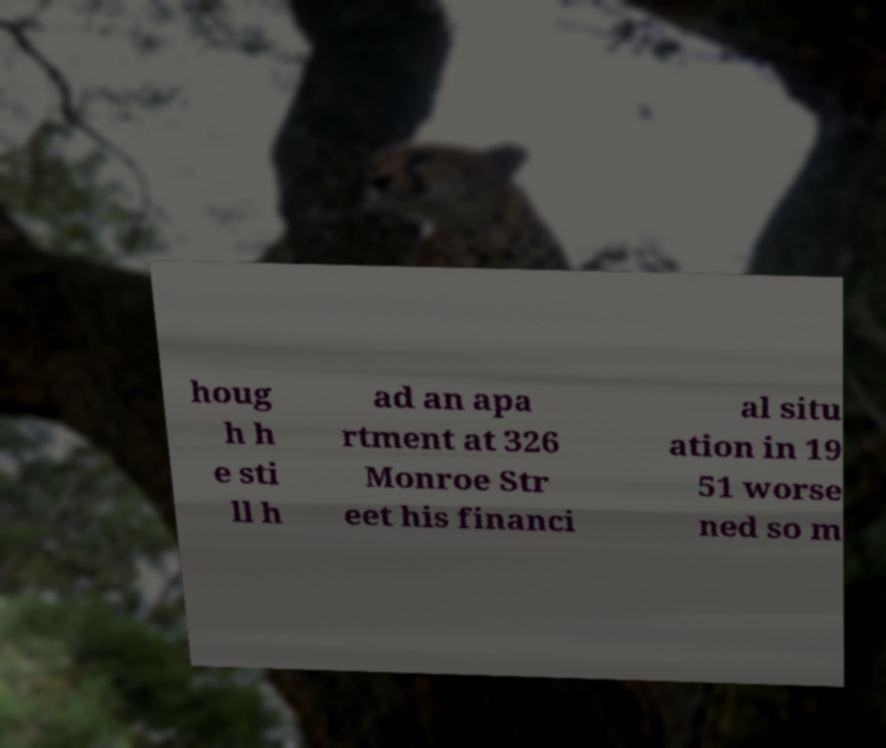Could you extract and type out the text from this image? houg h h e sti ll h ad an apa rtment at 326 Monroe Str eet his financi al situ ation in 19 51 worse ned so m 